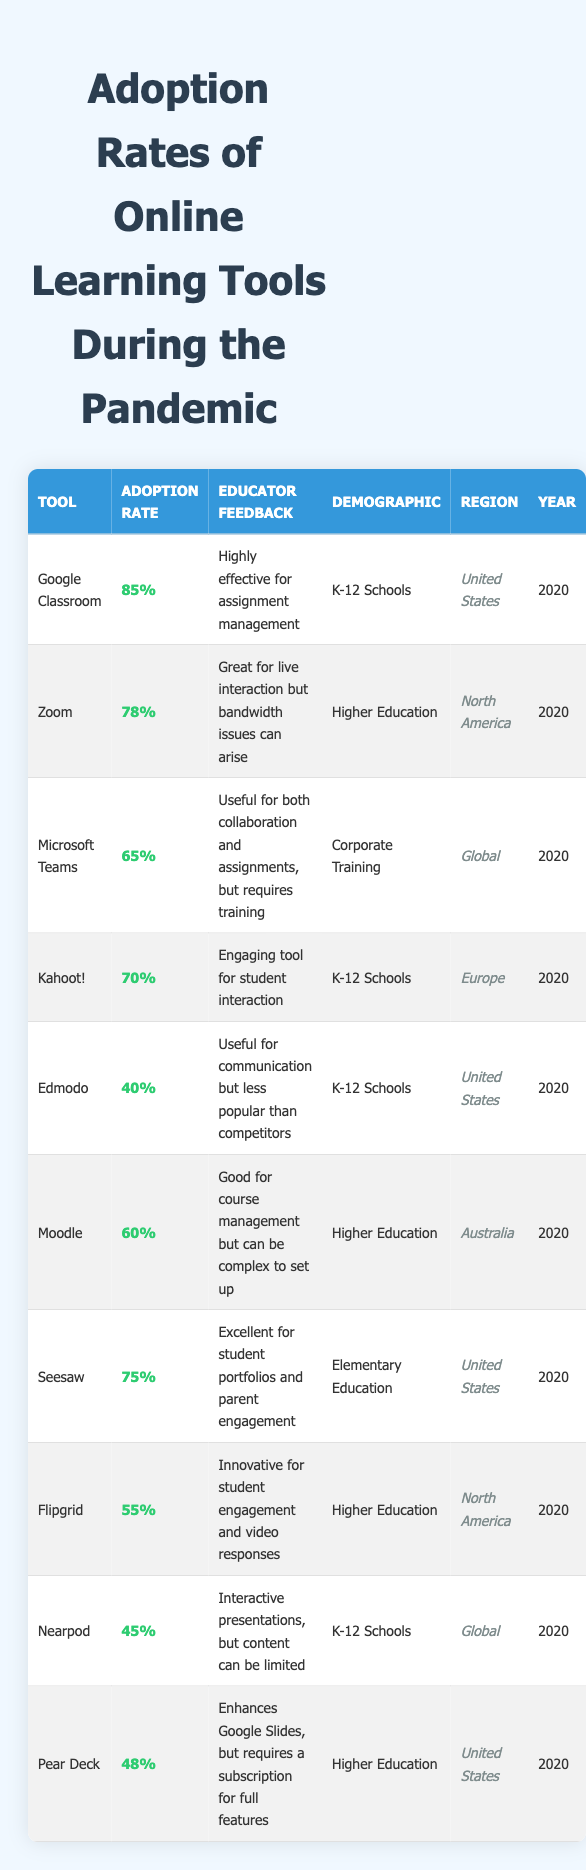What is the adoption rate of Google Classroom? The table shows that the adoption rate for Google Classroom is listed as 85%.
Answer: 85% Which tool has the highest adoption rate among K-12 schools? The table indicates that Google Classroom (85%) has the highest adoption rate among K-12 schools. Kahoot! is next at 70%.
Answer: Google Classroom How many tools have an adoption rate above 70%? The table lists Google Classroom (85%), Zoom (78%), Seesaw (75%), and Kahoot! (70%) as having adoption rates above 70%. That makes a total of 4 tools.
Answer: 4 Is the adoption rate of Edmodo above 30%? The adoption rate for Edmodo is given as 40%, which is above 30%.
Answer: Yes What is the average adoption rate for tools used in Higher Education? The adoption rates for Higher Education tools are Zoom (78%), Moodle (60%), and Flipgrid (55%). To find the average, we sum these rates (78 + 60 + 55 = 193) and divide by 3. This gives us an average adoption rate of 64.33%.
Answer: 64.33% How does the adoption rate of Microsoft Teams compare to that of Nearpod? Microsoft Teams has an adoption rate of 65%, while Nearpod has a rate of 45%. This indicates that Microsoft Teams has a higher adoption rate than Nearpod by 20 percentage points.
Answer: Microsoft Teams is higher by 20% Which region has the tool with the lowest adoption rate listed? According to the table, Edmodo (40%) has the lowest adoption rate, and it is used in the United States. This confirms that the region with the lowest adoption rate is the United States.
Answer: United States Which tool is most favored by educators for live interaction? The feedback for Zoom indicated it is "Great for live interaction but bandwidth issues can arise," positioning it as the most favored for live interaction.
Answer: Zoom Which demographic has the lowest overall adoption rates for any tool? When checking K-12 Schools in general, Edmodo (40%) and Nearpod (45%) represent the lowest overall adoption rates within that demographic. Among these, Edmodo has the lowest.
Answer: K-12 Schools If we sum the adoption rates for all tools listed, what is the total? Adding together the listed adoption rates (85 + 78 + 65 + 70 + 40 + 60 + 75 + 55 + 45 + 48) gives us a total of 726.
Answer: 726 